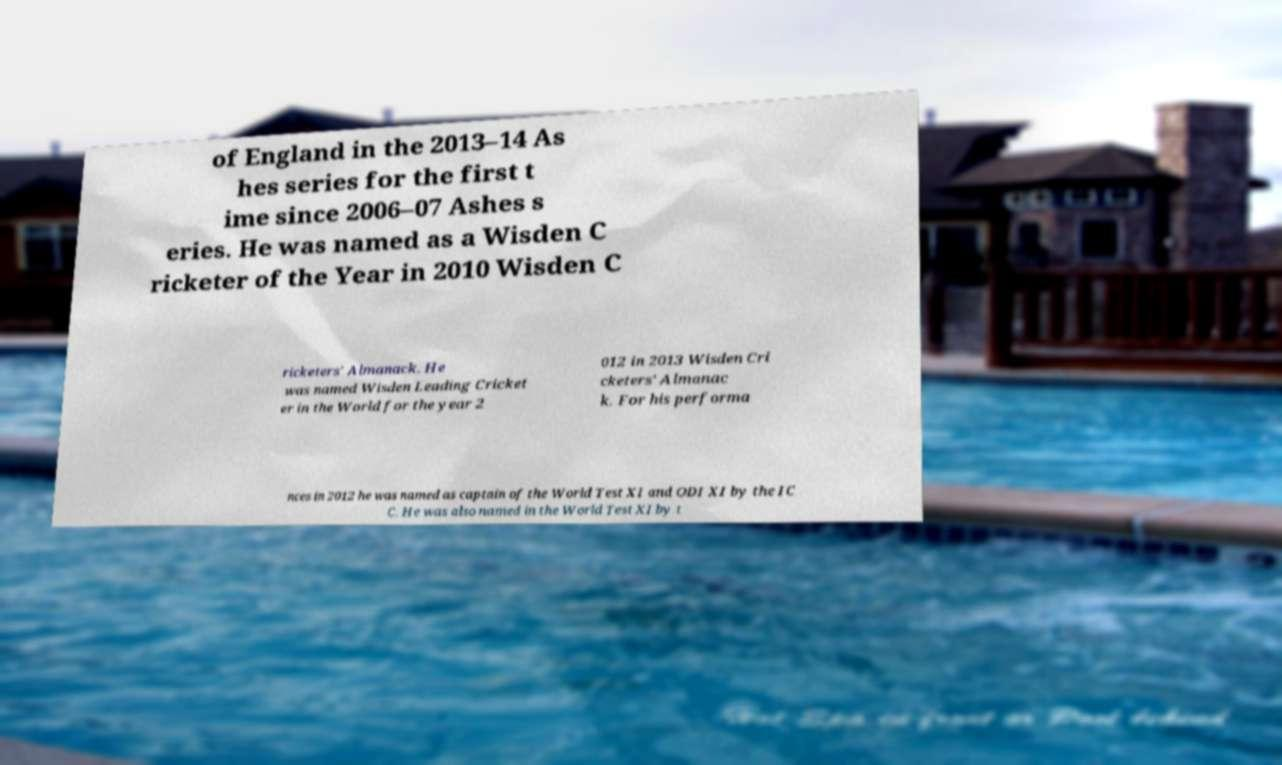Can you read and provide the text displayed in the image?This photo seems to have some interesting text. Can you extract and type it out for me? of England in the 2013–14 As hes series for the first t ime since 2006–07 Ashes s eries. He was named as a Wisden C ricketer of the Year in 2010 Wisden C ricketers' Almanack. He was named Wisden Leading Cricket er in the World for the year 2 012 in 2013 Wisden Cri cketers' Almanac k. For his performa nces in 2012 he was named as captain of the World Test XI and ODI XI by the IC C. He was also named in the World Test XI by t 